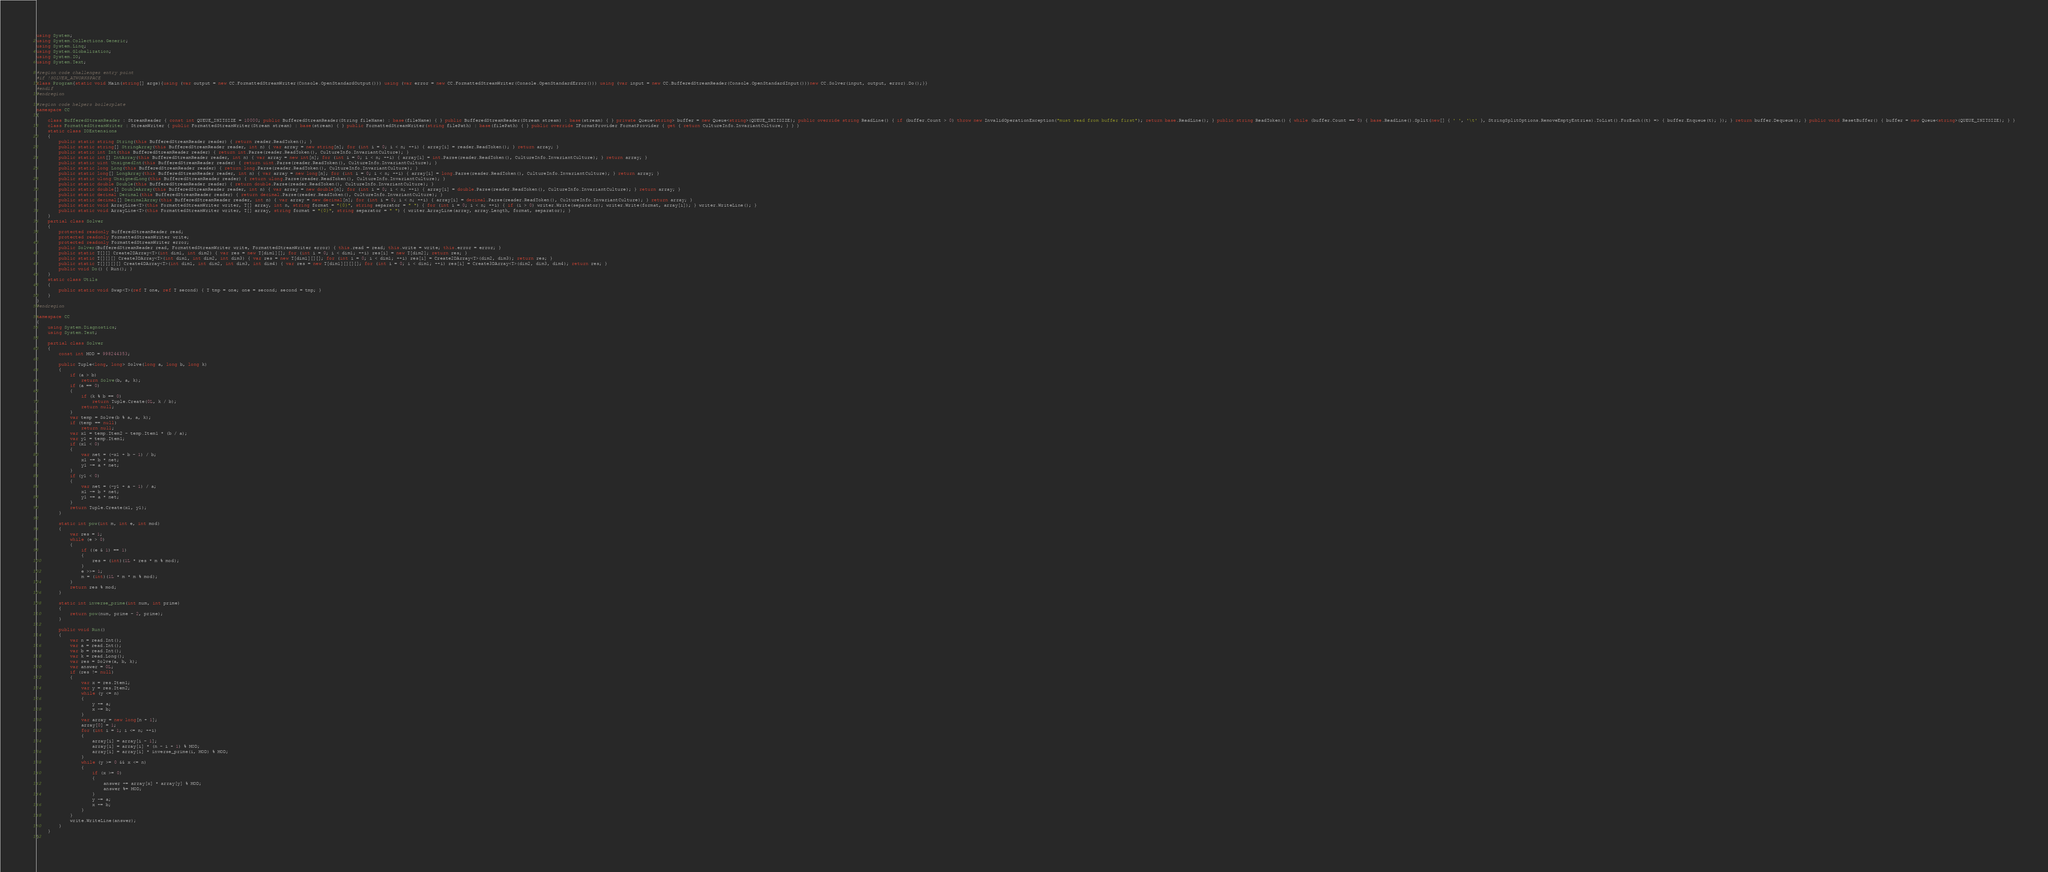Convert code to text. <code><loc_0><loc_0><loc_500><loc_500><_C#_>using System;
using System.Collections.Generic;
using System.Linq;
using System.Globalization;
using System.IO;
using System.Text;

#region code challenges entry point
#if !SOLVER_ATWORKSPACE
class Program{static void Main(string[] args){using (var output = new CC.FormattedStreamWriter(Console.OpenStandardOutput())) using (var error = new CC.FormattedStreamWriter(Console.OpenStandardError())) using (var input = new CC.BufferedStreamReader(Console.OpenStandardInput()))new CC.Solver(input, output, error).Do();}}
#endif
#endregion

#region code helpers boilerplate
namespace CC
{
    class BufferedStreamReader : StreamReader { const int QUEUE_INITSIZE = 10000; public BufferedStreamReader(String fileName) : base(fileName) { } public BufferedStreamReader(Stream stream) : base(stream) { } private Queue<string> buffer = new Queue<string>(QUEUE_INITSIZE); public override string ReadLine() { if (buffer.Count > 0) throw new InvalidOperationException("must read from buffer first"); return base.ReadLine(); } public string ReadToken() { while (buffer.Count == 0) { base.ReadLine().Split(new[] { ' ', '\t' }, StringSplitOptions.RemoveEmptyEntries).ToList().ForEach((t) => { buffer.Enqueue(t); }); } return buffer.Dequeue(); } public void ResetBuffer() { buffer = new Queue<string>(QUEUE_INITSIZE); } }
    class FormattedStreamWriter : StreamWriter { public FormattedStreamWriter(Stream stream) : base(stream) { } public FormattedStreamWriter(string filePath) : base(filePath) { } public override IFormatProvider FormatProvider { get { return CultureInfo.InvariantCulture; } } }
    static class IOExtensions
    {
        public static string String(this BufferedStreamReader reader) { return reader.ReadToken(); }
        public static string[] StringArray(this BufferedStreamReader reader, int n) { var array = new string[n]; for (int i = 0; i < n; ++i) { array[i] = reader.ReadToken(); } return array; }
        public static int Int(this BufferedStreamReader reader) { return int.Parse(reader.ReadToken(), CultureInfo.InvariantCulture); }
        public static int[] IntArray(this BufferedStreamReader reader, int n) { var array = new int[n]; for (int i = 0; i < n; ++i) { array[i] = int.Parse(reader.ReadToken(), CultureInfo.InvariantCulture); } return array; }
        public static uint UnsignedInt(this BufferedStreamReader reader) { return uint.Parse(reader.ReadToken(), CultureInfo.InvariantCulture); }
        public static long Long(this BufferedStreamReader reader) { return long.Parse(reader.ReadToken(), CultureInfo.InvariantCulture); }
        public static long[] LongArray(this BufferedStreamReader reader, int n) { var array = new long[n]; for (int i = 0; i < n; ++i) { array[i] = long.Parse(reader.ReadToken(), CultureInfo.InvariantCulture); } return array; }
        public static ulong UnsignedLong(this BufferedStreamReader reader) { return ulong.Parse(reader.ReadToken(), CultureInfo.InvariantCulture); }
        public static double Double(this BufferedStreamReader reader) { return double.Parse(reader.ReadToken(), CultureInfo.InvariantCulture); }
        public static double[] DoubleArray(this BufferedStreamReader reader, int n) { var array = new double[n]; for (int i = 0; i < n; ++i) { array[i] = double.Parse(reader.ReadToken(), CultureInfo.InvariantCulture); } return array; }
        public static decimal Decimal(this BufferedStreamReader reader) { return decimal.Parse(reader.ReadToken(), CultureInfo.InvariantCulture); }
        public static decimal[] DecimalArray(this BufferedStreamReader reader, int n) { var array = new decimal[n]; for (int i = 0; i < n; ++i) { array[i] = decimal.Parse(reader.ReadToken(), CultureInfo.InvariantCulture); } return array; }
        public static void ArrayLine<T>(this FormattedStreamWriter writer, T[] array, int n, string format = "{0}", string separator = " ") { for (int i = 0; i < n; ++i) { if (i > 0) writer.Write(separator); writer.Write(format, array[i]); } writer.WriteLine(); }
        public static void ArrayLine<T>(this FormattedStreamWriter writer, T[] array, string format = "{0}", string separator = " ") { writer.ArrayLine(array, array.Length, format, separator); }
    }
    partial class Solver
    {
        protected readonly BufferedStreamReader read;
        protected readonly FormattedStreamWriter write;
        protected readonly FormattedStreamWriter error;
        public Solver(BufferedStreamReader read, FormattedStreamWriter write, FormattedStreamWriter error) { this.read = read; this.write = write; this.error = error; }
        public static T[][] Create2DArray<T>(int dim1, int dim2) { var res = new T[dim1][]; for (int i = 0; i < dim1; ++i) res[i] = new T[dim2]; return res; }
        public static T[][][] Create3DArray<T>(int dim1, int dim2, int dim3) { var res = new T[dim1][][]; for (int i = 0; i < dim1; ++i) res[i] = Create2DArray<T>(dim2, dim3); return res; }
        public static T[][][][] Create4DArray<T>(int dim1, int dim2, int dim3, int dim4) { var res = new T[dim1][][][]; for (int i = 0; i < dim1; ++i) res[i] = Create3DArray<T>(dim2, dim3, dim4); return res; }
        public void Do() { Run(); }
    }
    static class Utils
    {
        public static void Swap<T>(ref T one, ref T second) { T tmp = one; one = second; second = tmp; }
    }
}
#endregion

namespace CC
{
    using System.Diagnostics;
    using System.Text;

    partial class Solver
    {
        const int MOD = 998244353;

        public Tuple<long, long> Solve(long a, long b, long k)
        {
            if (a > b)
                return Solve(b, a, k);
            if (a == 0)
            {
                if (k % b == 0)
                    return Tuple.Create(0L, k / b);
                return null;
            }
            var temp = Solve(b % a, a, k);
            if (temp == null)
                return null;
            var x1 = temp.Item2 - temp.Item1 * (b / a);
            var y1 = temp.Item1;
            if (x1 < 0)
            {
                var net = (-x1 + b - 1) / b;
                x1 += b * net;
                y1 -= a * net;
            }
            if (y1 < 0)
            {
                var net = (-y1 + a - 1) / a;
                x1 -= b * net;
                y1 += a * net;
            }
            return Tuple.Create(x1, y1);
        }

        static int pow(int m, int e, int mod)
        {
            var res = 1;
            while (e > 0)
            {
                if ((e & 1) == 1)
                {
                    res = (int)(1L * res * m % mod);
                }
                e >>= 1;
                m = (int)(1L * m * m % mod);
            }
            return res % mod;
        }

        static int inverse_prime(int num, int prime)
        {
            return pow(num, prime - 2, prime);
        }

        public void Run()
        {            
            var n = read.Int();
            var a = read.Int();
            var b = read.Int();
            var k = read.Long();
            var res = Solve(a, b, k);
            var answer = 0L;
            if (res != null)
            {
                var x = res.Item1;
                var y = res.Item2;
                while (y <= n)
                {
                    y += a;
                    x -= b;
                }
                var array = new long[n + 1];
                array[0] = 1;
                for (int i = 1; i <= n; ++i)
                {
                    array[i] = array[i - 1];                    
                    array[i] = array[i] * (n - i + 1) % MOD;
                    array[i] = array[i] * inverse_prime(i, MOD) % MOD;
                }
                while (y >= 0 && x <= n)
                {
                    if (x >= 0)
                    {
                        answer += array[x] * array[y] % MOD;
                        answer %= MOD;
                    }
                    y -= a;
                    x += b;
                }
            }
            write.WriteLine(answer);
        }
    }
}</code> 